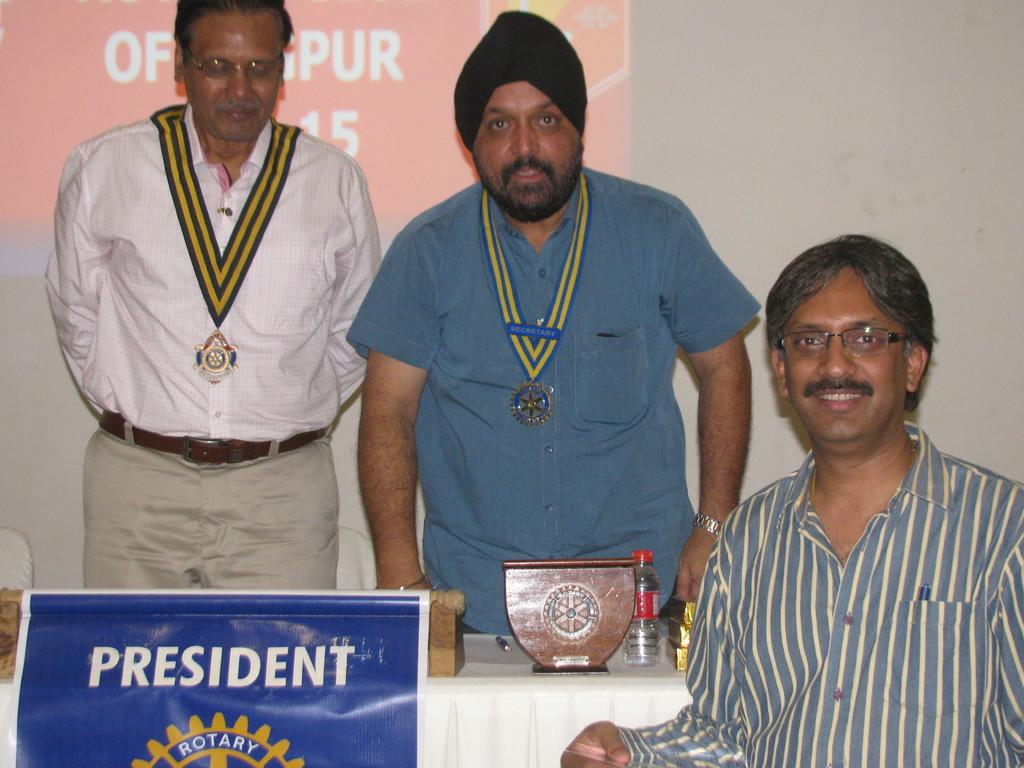<image>
Relay a brief, clear account of the picture shown. a sign that says President on it with people around 